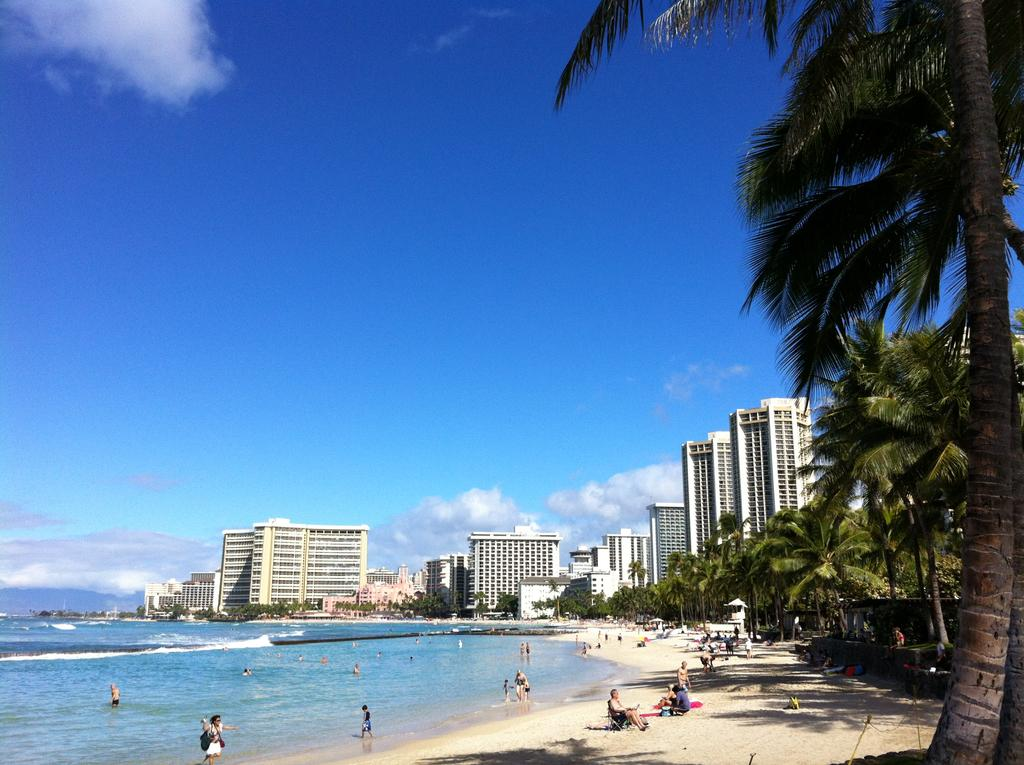What type of location is shown in the image? The image depicts a city. Can you describe the people in the image? There is a group of people in the image. What natural feature can be seen in the image? There is a beach in the image. What man-made structures are present in the image? There are buildings in the image. What type of vegetation is visible in the image? There are trees in the image. What is visible in the background of the image? The sky is visible in the background of the image. What is the cause of the water flowing uphill in the image? There is no water flowing uphill in the image; it does not depict any such phenomenon. 